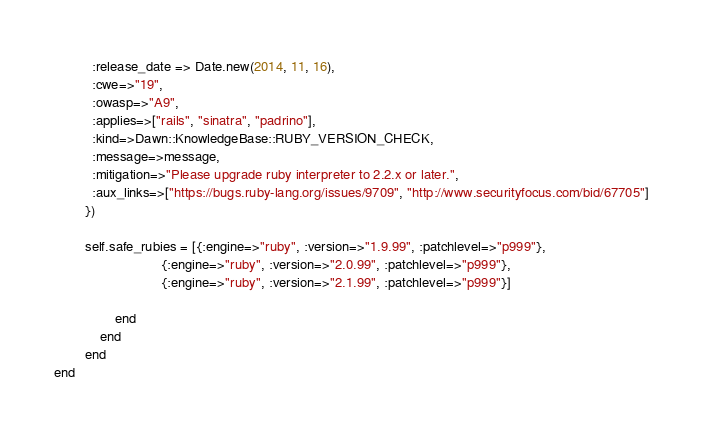Convert code to text. <code><loc_0><loc_0><loc_500><loc_500><_Ruby_>          :release_date => Date.new(2014, 11, 16),
          :cwe=>"19",
          :owasp=>"A9",
          :applies=>["rails", "sinatra", "padrino"],
          :kind=>Dawn::KnowledgeBase::RUBY_VERSION_CHECK,
          :message=>message,
          :mitigation=>"Please upgrade ruby interpreter to 2.2.x or later.",
          :aux_links=>["https://bugs.ruby-lang.org/issues/9709", "http://www.securityfocus.com/bid/67705"]
        })

        self.safe_rubies = [{:engine=>"ruby", :version=>"1.9.99", :patchlevel=>"p999"},
                            {:engine=>"ruby", :version=>"2.0.99", :patchlevel=>"p999"},
                            {:engine=>"ruby", :version=>"2.1.99", :patchlevel=>"p999"}]

				end
			end
		end
end
</code> 